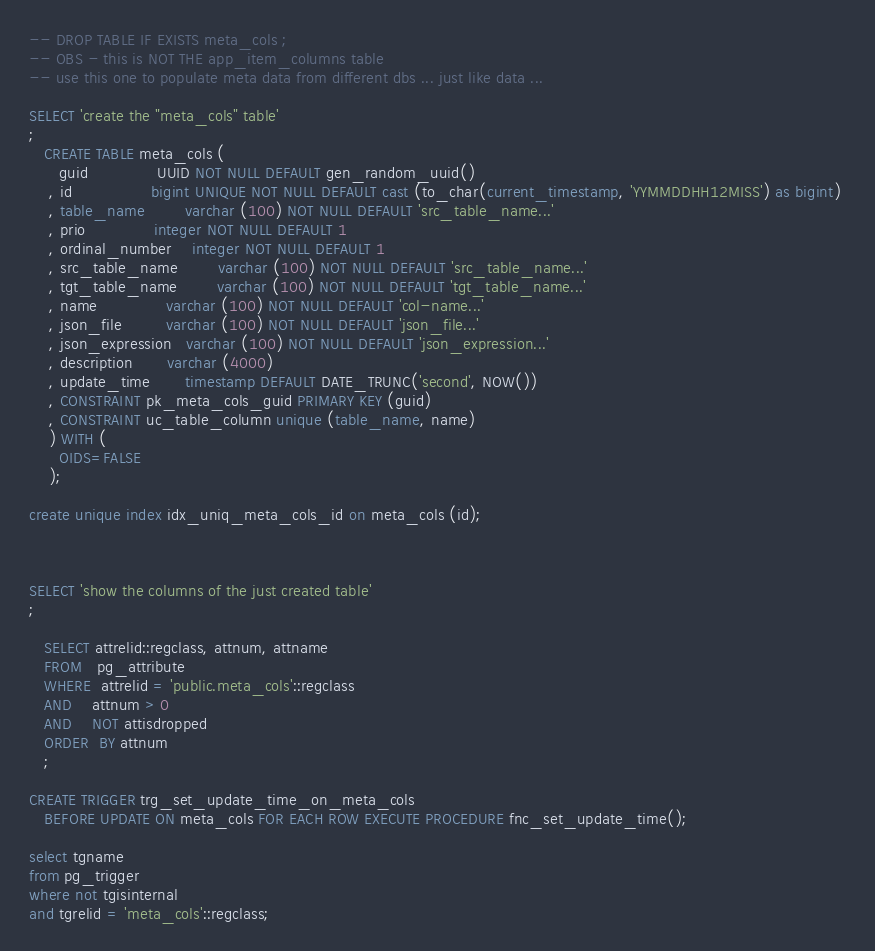<code> <loc_0><loc_0><loc_500><loc_500><_SQL_>-- DROP TABLE IF EXISTS meta_cols ; 
-- OBS - this is NOT THE app_item_columns table 
-- use this one to populate meta data from different dbs ... just like data ... 

SELECT 'create the "meta_cols" table'
; 
   CREATE TABLE meta_cols (
      guid              UUID NOT NULL DEFAULT gen_random_uuid()
    , id                bigint UNIQUE NOT NULL DEFAULT cast (to_char(current_timestamp, 'YYMMDDHH12MISS') as bigint) 
    , table_name        varchar (100) NOT NULL DEFAULT 'src_table_name...'
    , prio              integer NOT NULL DEFAULT 1
    , ordinal_number    integer NOT NULL DEFAULT 1
    , src_table_name        varchar (100) NOT NULL DEFAULT 'src_table_name...'
    , tgt_table_name        varchar (100) NOT NULL DEFAULT 'tgt_table_name...'
    , name              varchar (100) NOT NULL DEFAULT 'col-name...'
    , json_file         varchar (100) NOT NULL DEFAULT 'json_file...'
    , json_expression   varchar (100) NOT NULL DEFAULT 'json_expression...'
    , description       varchar (4000)
    , update_time       timestamp DEFAULT DATE_TRUNC('second', NOW())
    , CONSTRAINT pk_meta_cols_guid PRIMARY KEY (guid)
    , CONSTRAINT uc_table_column unique (table_name, name)
    ) WITH (
      OIDS=FALSE
    );

create unique index idx_uniq_meta_cols_id on meta_cols (id);



SELECT 'show the columns of the just created table'
; 

   SELECT attrelid::regclass, attnum, attname
   FROM   pg_attribute
   WHERE  attrelid = 'public.meta_cols'::regclass
   AND    attnum > 0
   AND    NOT attisdropped
   ORDER  BY attnum
   ; 

CREATE TRIGGER trg_set_update_time_on_meta_cols 
   BEFORE UPDATE ON meta_cols FOR EACH ROW EXECUTE PROCEDURE fnc_set_update_time();

select tgname
from pg_trigger
where not tgisinternal
and tgrelid = 'meta_cols'::regclass;

</code> 